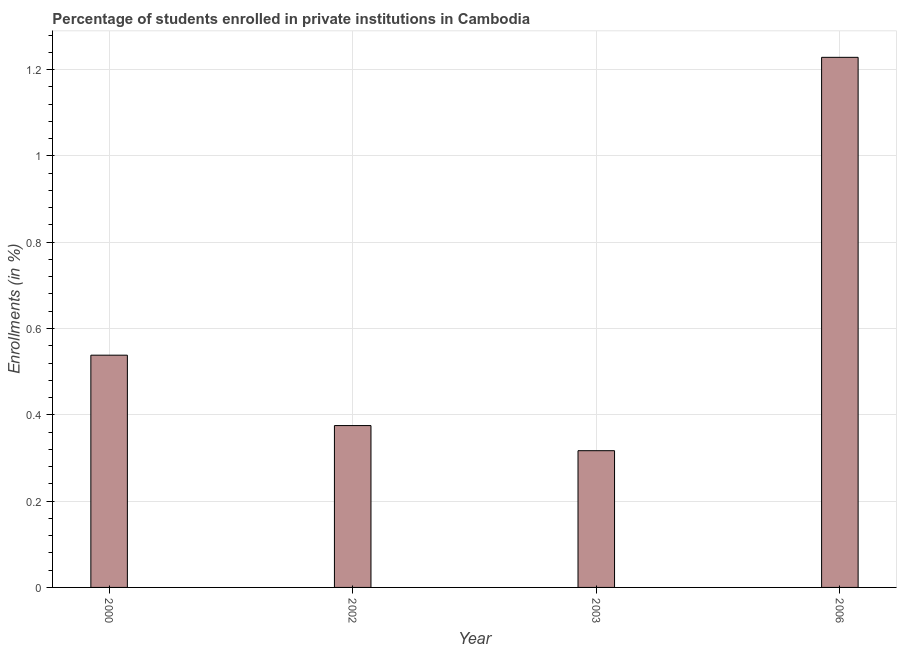What is the title of the graph?
Give a very brief answer. Percentage of students enrolled in private institutions in Cambodia. What is the label or title of the Y-axis?
Provide a succinct answer. Enrollments (in %). What is the enrollments in private institutions in 2003?
Provide a succinct answer. 0.32. Across all years, what is the maximum enrollments in private institutions?
Make the answer very short. 1.23. Across all years, what is the minimum enrollments in private institutions?
Make the answer very short. 0.32. In which year was the enrollments in private institutions maximum?
Keep it short and to the point. 2006. In which year was the enrollments in private institutions minimum?
Give a very brief answer. 2003. What is the sum of the enrollments in private institutions?
Offer a very short reply. 2.46. What is the difference between the enrollments in private institutions in 2002 and 2006?
Your response must be concise. -0.85. What is the average enrollments in private institutions per year?
Provide a succinct answer. 0.61. What is the median enrollments in private institutions?
Offer a very short reply. 0.46. In how many years, is the enrollments in private institutions greater than 0.24 %?
Keep it short and to the point. 4. What is the ratio of the enrollments in private institutions in 2000 to that in 2002?
Provide a succinct answer. 1.44. Is the difference between the enrollments in private institutions in 2002 and 2006 greater than the difference between any two years?
Provide a succinct answer. No. What is the difference between the highest and the second highest enrollments in private institutions?
Give a very brief answer. 0.69. Is the sum of the enrollments in private institutions in 2002 and 2006 greater than the maximum enrollments in private institutions across all years?
Offer a terse response. Yes. What is the difference between the highest and the lowest enrollments in private institutions?
Your response must be concise. 0.91. What is the difference between two consecutive major ticks on the Y-axis?
Your response must be concise. 0.2. What is the Enrollments (in %) of 2000?
Your answer should be very brief. 0.54. What is the Enrollments (in %) of 2002?
Provide a succinct answer. 0.38. What is the Enrollments (in %) of 2003?
Your response must be concise. 0.32. What is the Enrollments (in %) of 2006?
Make the answer very short. 1.23. What is the difference between the Enrollments (in %) in 2000 and 2002?
Ensure brevity in your answer.  0.16. What is the difference between the Enrollments (in %) in 2000 and 2003?
Your response must be concise. 0.22. What is the difference between the Enrollments (in %) in 2000 and 2006?
Give a very brief answer. -0.69. What is the difference between the Enrollments (in %) in 2002 and 2003?
Offer a terse response. 0.06. What is the difference between the Enrollments (in %) in 2002 and 2006?
Your response must be concise. -0.85. What is the difference between the Enrollments (in %) in 2003 and 2006?
Provide a succinct answer. -0.91. What is the ratio of the Enrollments (in %) in 2000 to that in 2002?
Offer a very short reply. 1.44. What is the ratio of the Enrollments (in %) in 2000 to that in 2003?
Your answer should be compact. 1.7. What is the ratio of the Enrollments (in %) in 2000 to that in 2006?
Provide a succinct answer. 0.44. What is the ratio of the Enrollments (in %) in 2002 to that in 2003?
Ensure brevity in your answer.  1.18. What is the ratio of the Enrollments (in %) in 2002 to that in 2006?
Keep it short and to the point. 0.3. What is the ratio of the Enrollments (in %) in 2003 to that in 2006?
Offer a terse response. 0.26. 